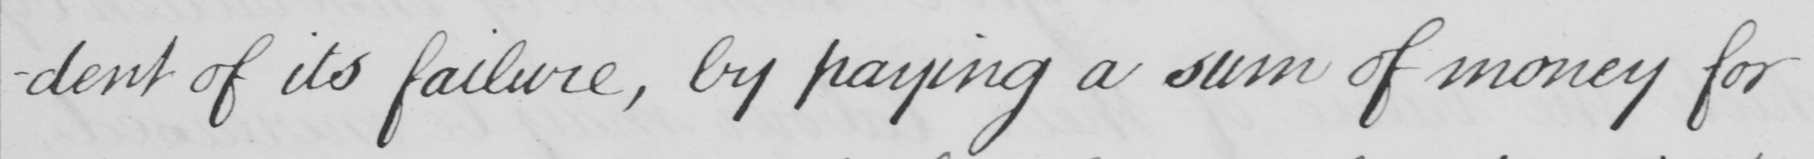Please transcribe the handwritten text in this image. -dent of its failure , by paying a sum of money for 